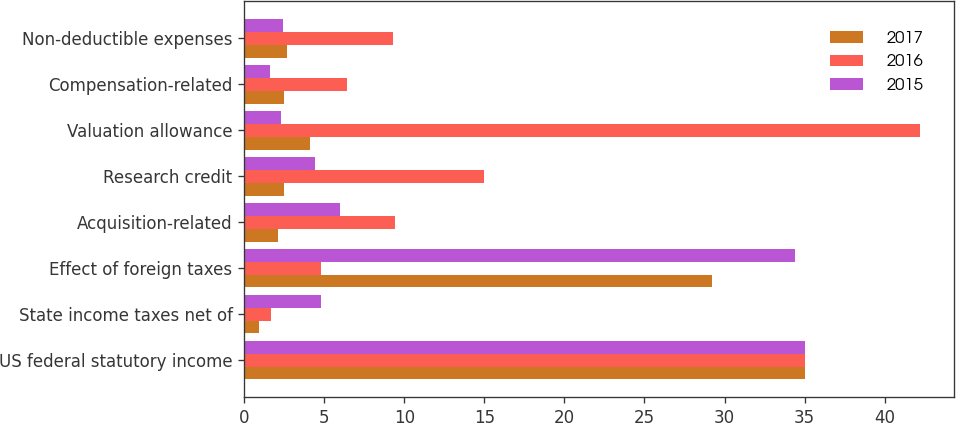<chart> <loc_0><loc_0><loc_500><loc_500><stacked_bar_chart><ecel><fcel>US federal statutory income<fcel>State income taxes net of<fcel>Effect of foreign taxes<fcel>Acquisition-related<fcel>Research credit<fcel>Valuation allowance<fcel>Compensation-related<fcel>Non-deductible expenses<nl><fcel>2017<fcel>35<fcel>0.9<fcel>29.2<fcel>2.1<fcel>2.5<fcel>4.1<fcel>2.5<fcel>2.7<nl><fcel>2016<fcel>35<fcel>1.7<fcel>4.8<fcel>9.4<fcel>15<fcel>42.2<fcel>6.4<fcel>9.3<nl><fcel>2015<fcel>35<fcel>4.8<fcel>34.4<fcel>6<fcel>4.4<fcel>2.3<fcel>1.6<fcel>2.4<nl></chart> 